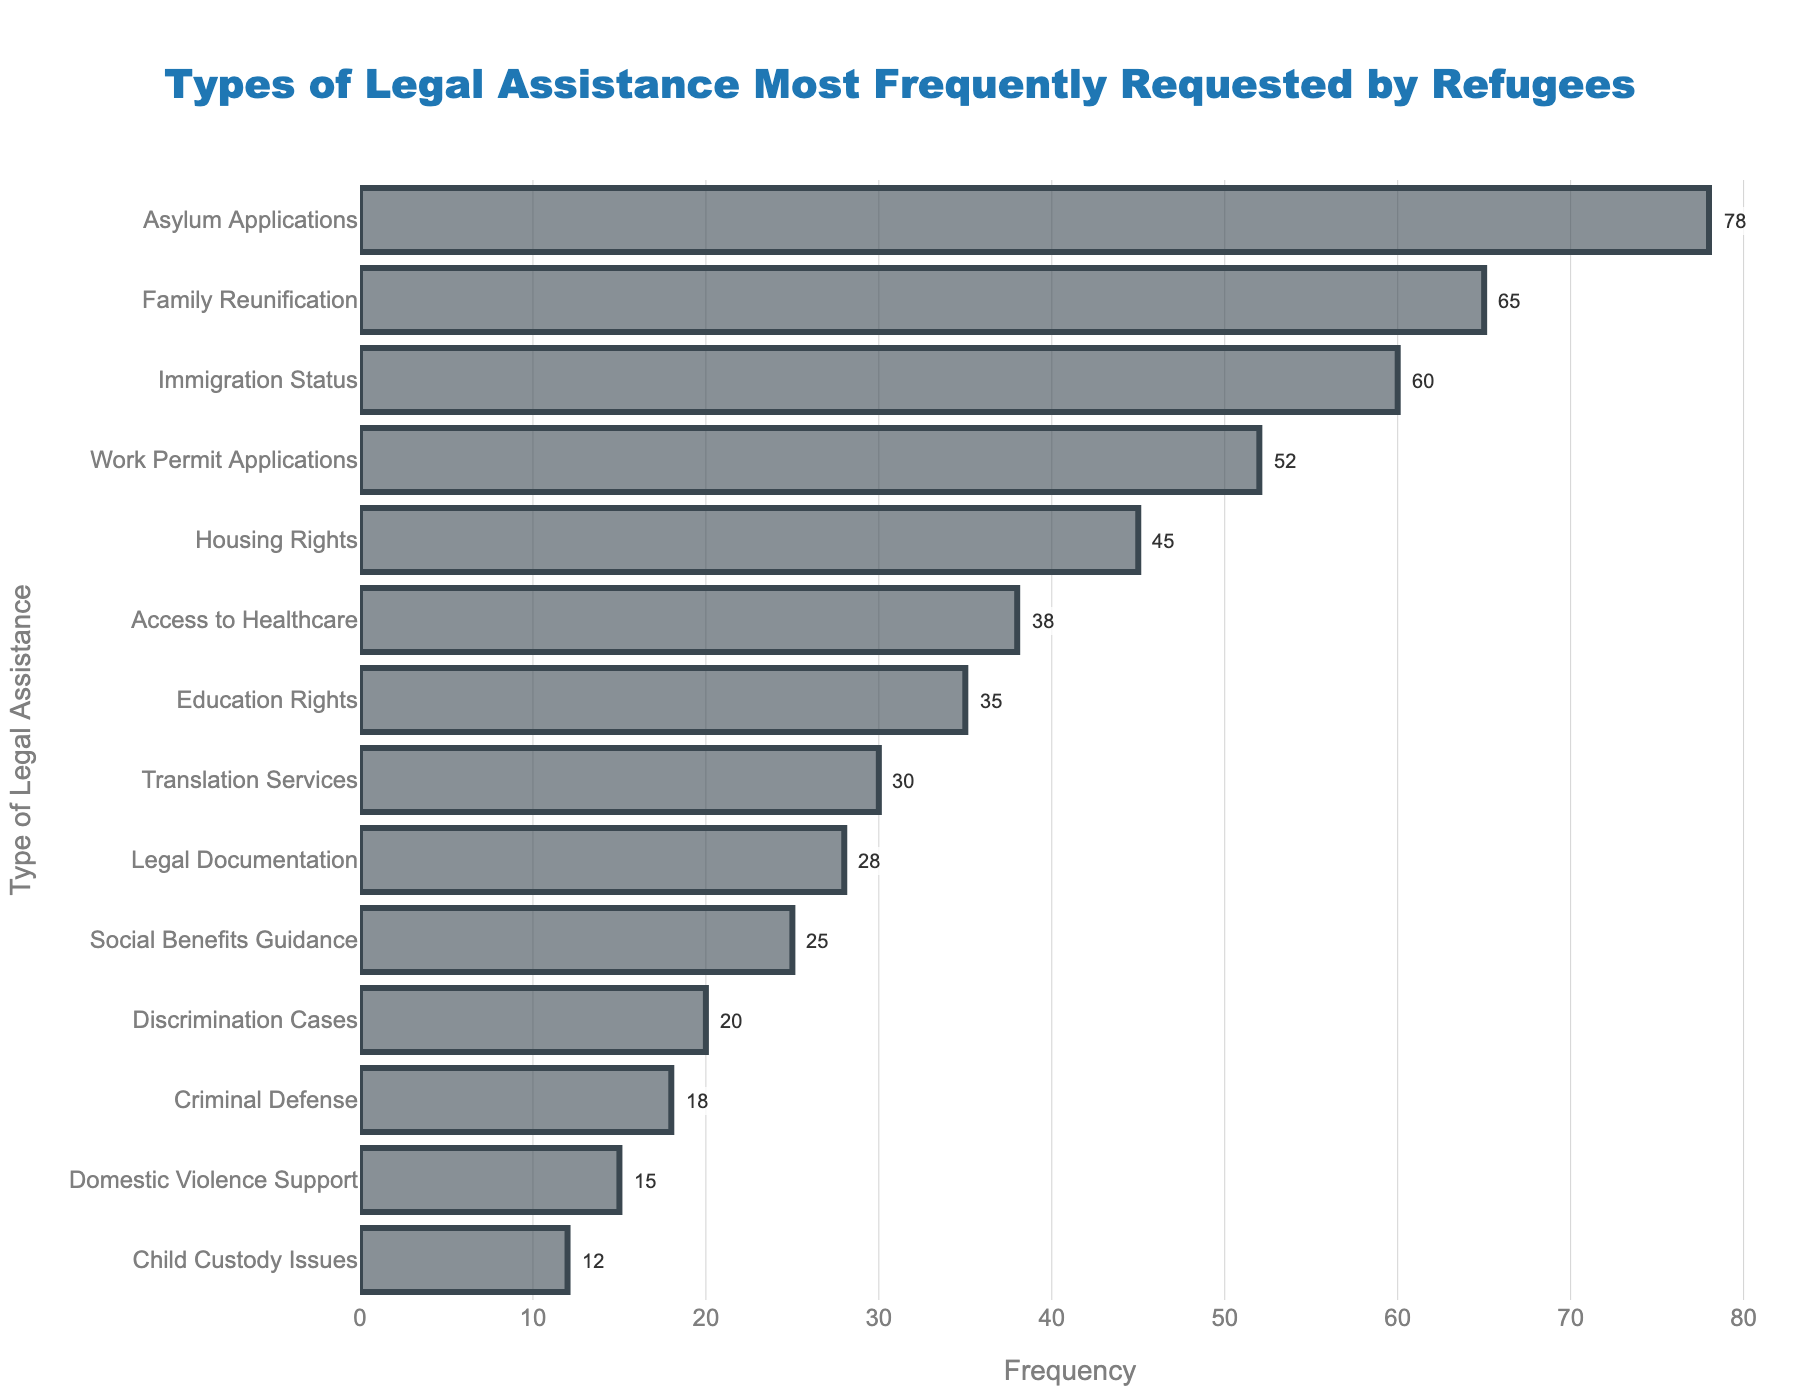What type of legal assistance is most frequently requested by refugees? The highest bar in the chart represents the most requested type of legal assistance. By viewing the top bar, it’s clear that "Asylum Applications" has the greatest frequency.
Answer: Asylum Applications What is the combined frequency of requests for Family Reunification and Immigration Status? Find the frequencies of Family Reunification (65) and Immigration Status (60) in the chart, and then add those two numbers together: 65 + 60 = 125.
Answer: 125 Which type of legal assistance has a slightly higher frequency than Work Permit Applications? In the chart, Work Permit Applications have a frequency of 52. The next highest frequency is 60, which is for Immigration Status.
Answer: Immigration Status How many more requests are there for Asylum Applications compared to Domestic Violence Support? The chart shows Asylum Applications at 78 and Domestic Violence Support at 15. The difference is calculated as 78 - 15 = 63.
Answer: 63 What is the total frequency of the least three requested types of legal assistance? The three least requested types are: Domestic Violence Support (15), Child Custody Issues (12), and Criminal Defense (18). Their combined frequency is 15 + 12 + 18 = 45.
Answer: 45 Among Housing Rights and Access to Healthcare, which one has fewer requests and by how many? Housing Rights have a frequency of 45 while Access to Healthcare has 38. The difference is 45 - 38 = 7, so Access to Healthcare has fewer requests by 7.
Answer: Access to Healthcare, 7 What is the median frequency value among all types of legal assistance requested? Arrange the frequencies in increasing order: 12, 15, 18, 20, 25, 28, 30, 35, 38, 45, 52, 60, 65, 78. The middle two numbers are 30 and 35, so the median is the average of these two: (30 + 35) / 2 = 32.5.
Answer: 32.5 How many types of legal assistance have a frequency higher than 50? By visually scanning the chart, note that there are five types of legal assistance with a frequency higher than 50: Asylum Applications, Family Reunification, Immigration Status, Work Permit Applications, and Housing Rights.
Answer: 4 Which two types of legal assistance have the closest frequencies? By comparing the heights of the bars, the frequencies for Legal Documentation (28) and Social Benefits Guidance (25) are the closest, differing by only 3 requests.
Answer: Legal Documentation and Social Benefits Guidance What percentage of total requests does Education Rights represent? First, sum the total frequency: 78 + 65 + 60 + 52 + 45 + 38 + 35 + 30 + 28 + 25 + 20 + 18 + 15 + 12 = 521. Then, calculate the percentage for Education Rights: (35 / 521) * 100 ≈ 6.72%.
Answer: 6.72% 